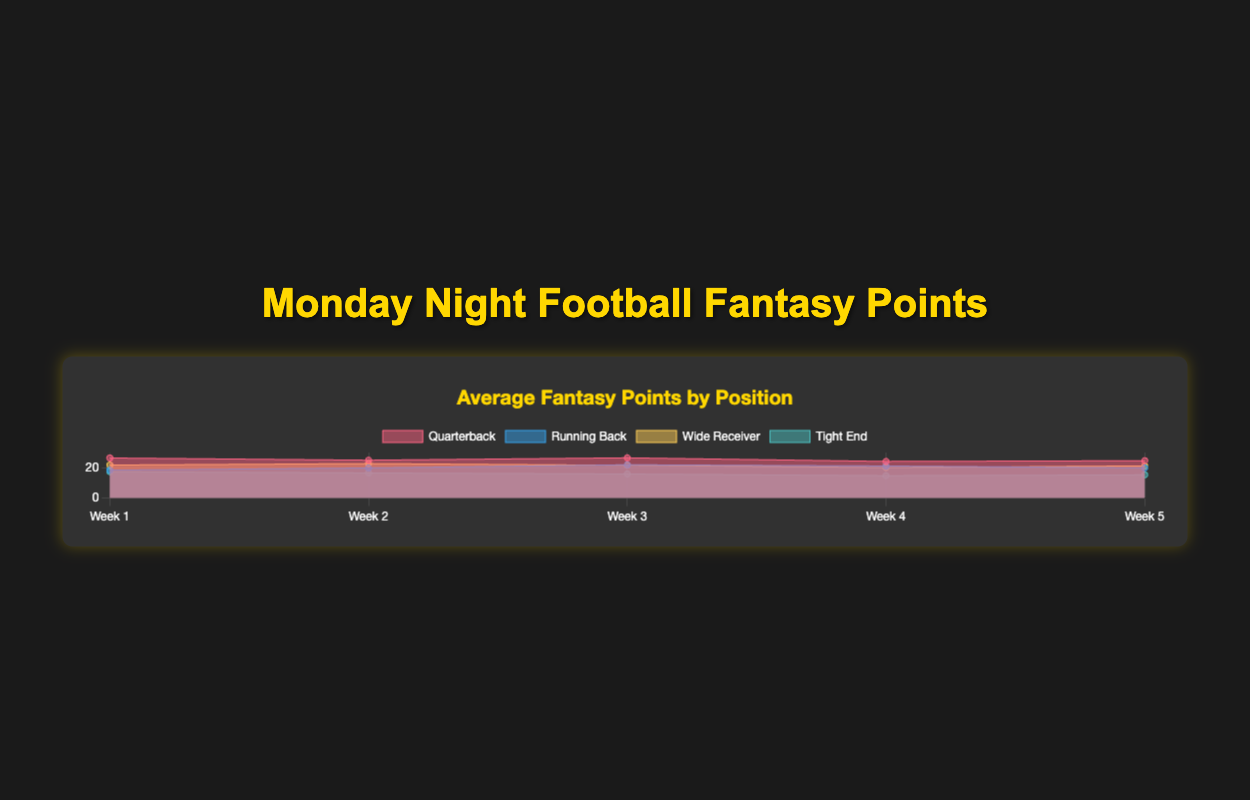What's the title of the chart? The title is prominently displayed at the top of the chart within the canvas container. It reads "Average Fantasy Points by Position".
Answer: Average Fantasy Points by Position How many weeks of data are shown in the chart? The chart shows time progression along the x-axis with labels indicating each week. Counting these labels gives the total number of weeks.
Answer: 5 What position has the highest average points in Week 2? Examining the vertical height of the datasets for Week 2 reveals that Wide Receivers have the highest average point value for that week.
Answer: Wide Receiver Which position shows a decreasing trend in points from Week 1 to Week 5? Tracking the overall slope of each positional dataset line shows that Tight End has a negative trend from Week 1 to Week 5.
Answer: Tight End Which week had the highest average fantasy points for Running Backs? The height of the Running Back dataset areas can be used to compare values over weeks. The highest point appears in Week 3.
Answer: Week 3 What's the range of average fantasy points for Quarterbacks from Week 1 to Week 5? The minimum and maximum values of the Quarterback dataset show that they range from the lowest value in Week 4 (24.7) to the highest in Week 1 (28.5). Thus, the difference is 28.5 - 24.7.
Answer: 3.8 By how much did the average fantasy points for Wide Receivers increase from Week 1 to Week 2? The values for Wide Receivers in Week 1 and Week 2 are found and their difference calculated: 24.1 - 22.9 = 1.2.
Answer: 1.2 What's the total sum of average fantasy points in Week 5 for all positions? Sum the average points across all positions in Week 5: for Quarterbacks (24.6 + 22.5)/2 = 24.6, Running Backs (20.9 + 18.9)/2 = 19.9, Wide Receivers (22.8 + 19.6)/2 = 21.2, Tight Ends (16.1 + 14.5)/2 = 15.3. Adding these values: 24.6 + 19.9 + 21.2 + 15.3 = 81.0.
Answer: 81.0 